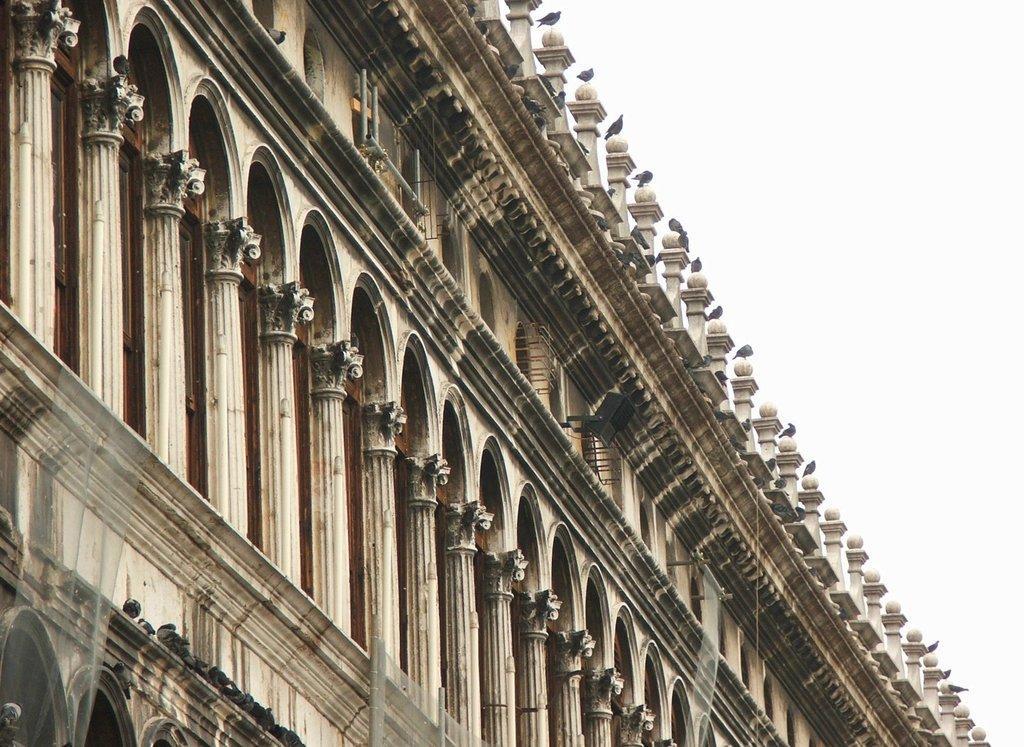Describe this image in one or two sentences. In this picture it looks like an old monument with stone walls, pillars, small windows. At the top we can see birds sitting on the pillars. 